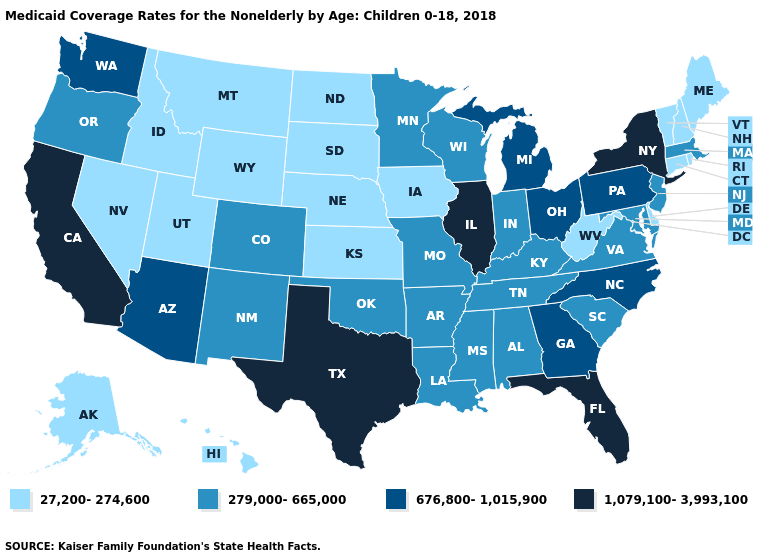What is the value of Alaska?
Concise answer only. 27,200-274,600. Among the states that border Connecticut , which have the lowest value?
Short answer required. Rhode Island. What is the lowest value in the Northeast?
Write a very short answer. 27,200-274,600. Among the states that border Oregon , does Idaho have the lowest value?
Give a very brief answer. Yes. What is the highest value in the USA?
Be succinct. 1,079,100-3,993,100. Does Wyoming have the lowest value in the USA?
Be succinct. Yes. Name the states that have a value in the range 676,800-1,015,900?
Concise answer only. Arizona, Georgia, Michigan, North Carolina, Ohio, Pennsylvania, Washington. What is the highest value in the MidWest ?
Answer briefly. 1,079,100-3,993,100. What is the lowest value in states that border Wyoming?
Answer briefly. 27,200-274,600. Name the states that have a value in the range 27,200-274,600?
Keep it brief. Alaska, Connecticut, Delaware, Hawaii, Idaho, Iowa, Kansas, Maine, Montana, Nebraska, Nevada, New Hampshire, North Dakota, Rhode Island, South Dakota, Utah, Vermont, West Virginia, Wyoming. What is the value of Iowa?
Concise answer only. 27,200-274,600. What is the value of Maine?
Give a very brief answer. 27,200-274,600. Does North Dakota have a higher value than Wyoming?
Write a very short answer. No. What is the highest value in the Northeast ?
Keep it brief. 1,079,100-3,993,100. Does the first symbol in the legend represent the smallest category?
Concise answer only. Yes. 